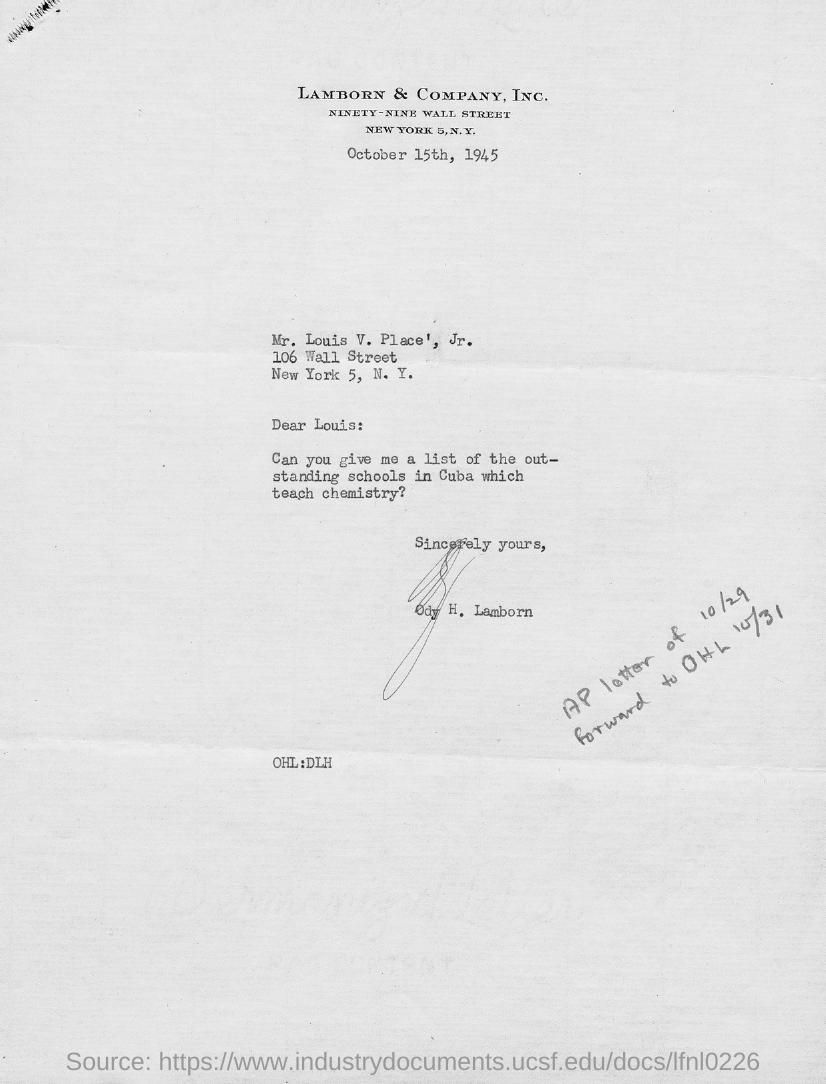Identify some key points in this picture. There are several outstanding schools in Cuba that teach chemistry. The letter is addressed to Mr. Louis V. Place, Jr. The letter is from Ody H. Lamborn. The date on the document is October 15th, 1945. 